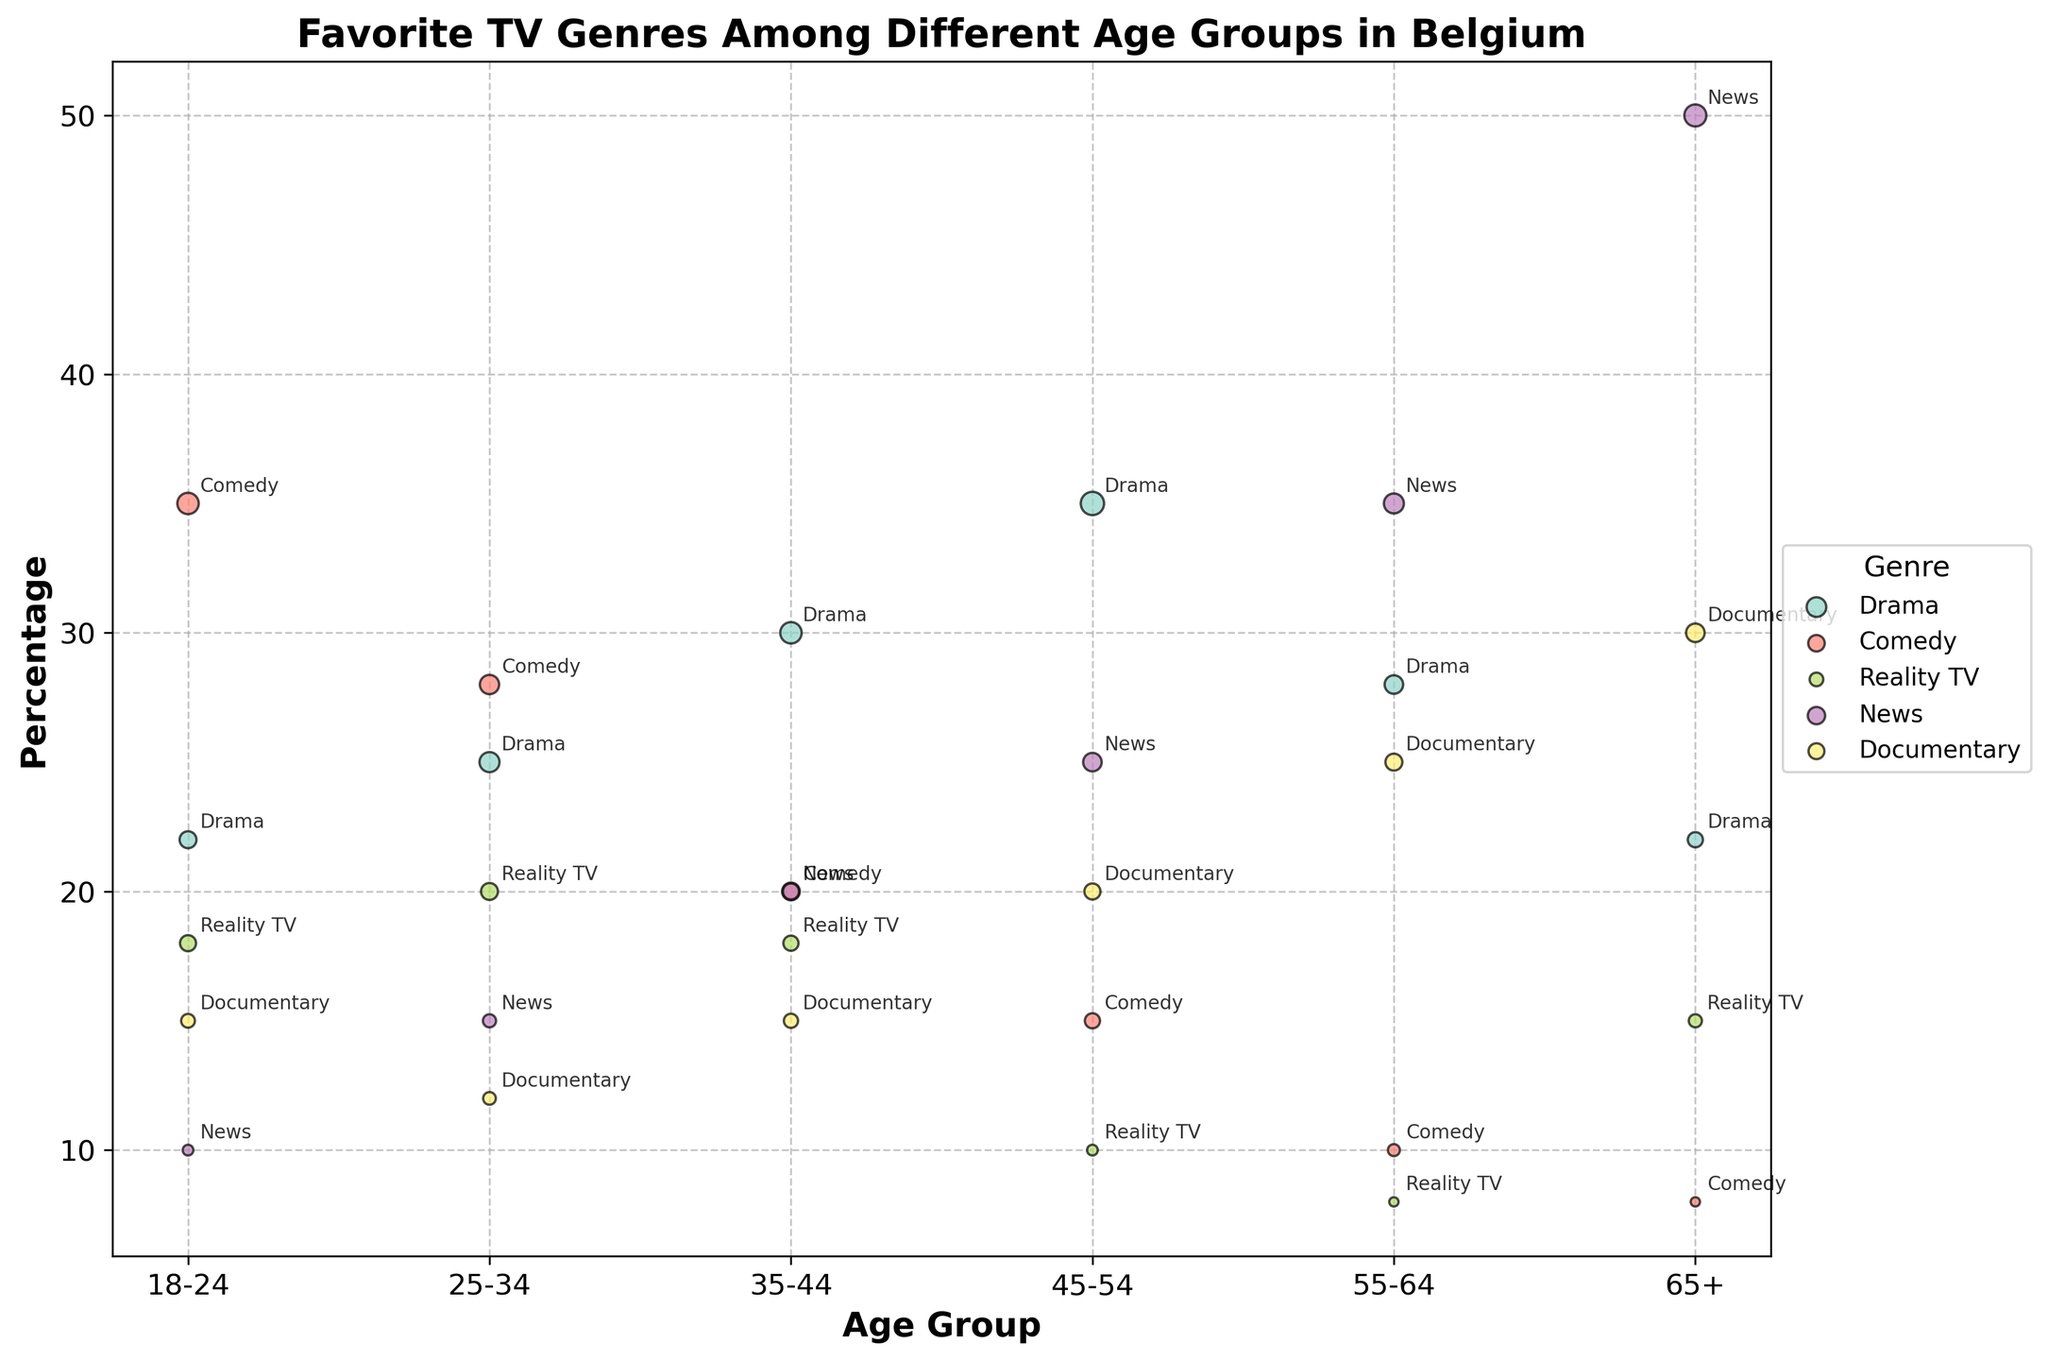What is the title of the figure? The title is typically displayed at the top of the figure. It provides a brief description of the visualized data.
Answer: Favorite TV Genres Among Different Age Groups in Belgium Which genre has the largest bubble for the 18-24 age group? To find this, we look at the size of the bubbles for the 18-24 age group and identify the largest one.
Answer: Comedy Which age group has the highest percentage for the News genre? For each age group, locate the percentage for the News genre and determine which is the highest.
Answer: 65+ What is the smallest bubble size for the Comedy genre, and which age group does it belong to? For the Comedy genre, identify the smallest bubble by comparing the sizes and note the corresponding age group.
Answer: 65+, 1500 Among all genres, which has the lowest percentage for the 55-64 age group? Compare the percentages of all genres for the 55-64 age group and identify the lowest one.
Answer: Reality TV How many age groups have a higher percentage for Documentary compared to News? For each age group, compare the percentages of Documentary and News to determine how many times Documentary has a higher percentage.
Answer: 2 Which genre shows an increasing trend in percentage as the age group increases? Examine the trend in percentage for each genre across increasing age groups to identify any genre with a positive trend.
Answer: News How does the viewership of Reality TV change from the 18-24 age group to the 65+ age group? Compare the viewership numbers for Reality TV from the 18-24 age group to the 65+ age group to observe the change.
Answer: Decreases from 4500 to 3000 Which age group has the most varied preferences in TV genres, considering both the percentage and viewership? Identify the age group by evaluating the difference in percentage and bubble sizes among the genres available.
Answer: 18-24 